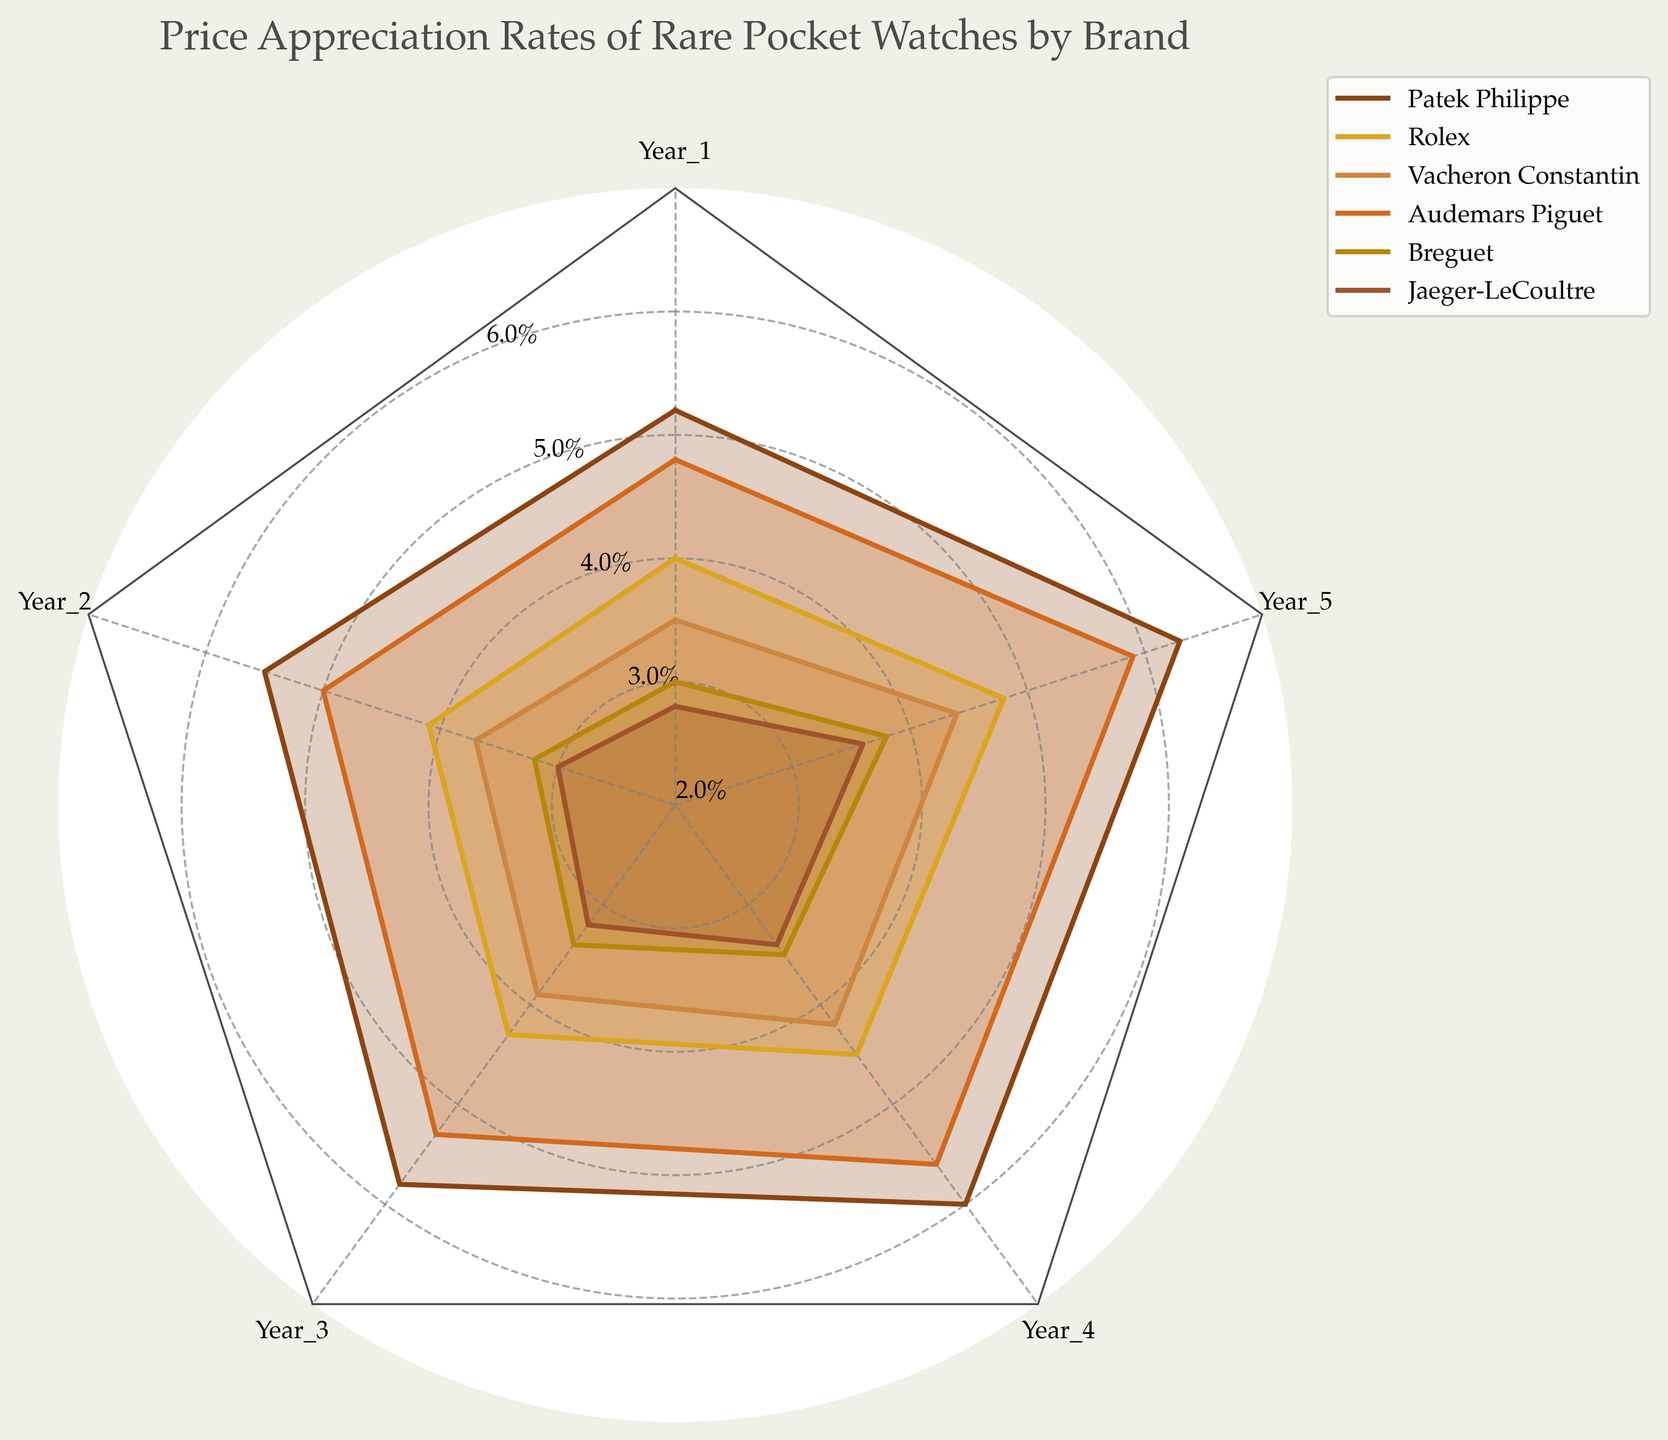What's the title of the radar chart? The title is usually displayed at the top of the radar chart and summarizes the overall content of the figure. The title helps in understanding the primary focus of the figure.
Answer: Price Appreciation Rates of Rare Pocket Watches by Brand What are the brands included in the radar chart? The brands are usually listed in the legend or can be identified by different colors in the chart. There are six distinct lines and corresponding labels.
Answer: Patek Philippe, Rolex, Vacheron Constantin, Audemars Piguet, Breguet, Jaeger-LeCoultre Which brand has the highest price appreciation rate in Year 5? To determine this, look at the outermost points (Year 5) for each brand and identify the one that is farthest from the center. The brand with the highest value in Year 5 will be furthest out.
Answer: Patek Philippe How does the price appreciation of Rolex in Year 3 compare to that in Year 1? Find the values of Rolex for Year 1 and Year 3 and compare them. From the visualized data, the distance from the center in respective years will help to understand the increment or change. Year 1 value is 4.0, and Year 3 value is 4.3, showing an increase.
Answer: Increased What's the range of price appreciation rates for Vacheron Constantin across the five years? Identify the lowest and the highest values for Vacheron Constantin over the five years by looking at the points for the brand. The range is calculated by subtracting the smallest value from the largest value.
Answer: 0.9 Which brand has the lowest average price appreciation rate over the five years? Calculate the average for each brand by summing up its values for the five years and dividing by 5. The brand with the smallest average is the one with the lowest rate.
Answer: Jaeger-LeCoultre Between Breguet and Jaeger-LeCoultre, which brand shows a higher price appreciation rate in Year 4 and by how much? Look at Year 4 values for both brands. Breguet has a value of 3.5, and Jaeger-LeCoultre has 3.4. Subtract the smaller value from the larger value to obtain the difference.
Answer: Breguet by 0.1 What trend is observed in the price appreciation rate of Audemars Piguet from Year 1 to Year 5? Observe the line representing Audemars Piguet over the five years to see whether it generally increases, decreases, or remains stable. The consistent increase from 4.8 to 5.9 indicates an upward trend.
Answer: Upward trend Which year shows the highest average appreciation rate across all brands? For each year, calculate the average by summing the values of all brands for that year and dividing by the number of brands (6 in this case). Compare these averages to find the highest one. Year 5 has the highest aggregated appreciations: (6.3 + 4.8 + 4.4 + 5.9 + 3.8 + 3.6) / 6 = approximately 4.80.
Answer: Year 5 